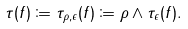<formula> <loc_0><loc_0><loc_500><loc_500>\tau ( f ) \coloneqq \tau _ { \rho , \epsilon } ( f ) \coloneqq \rho \wedge \tau _ { \epsilon } ( f ) .</formula> 